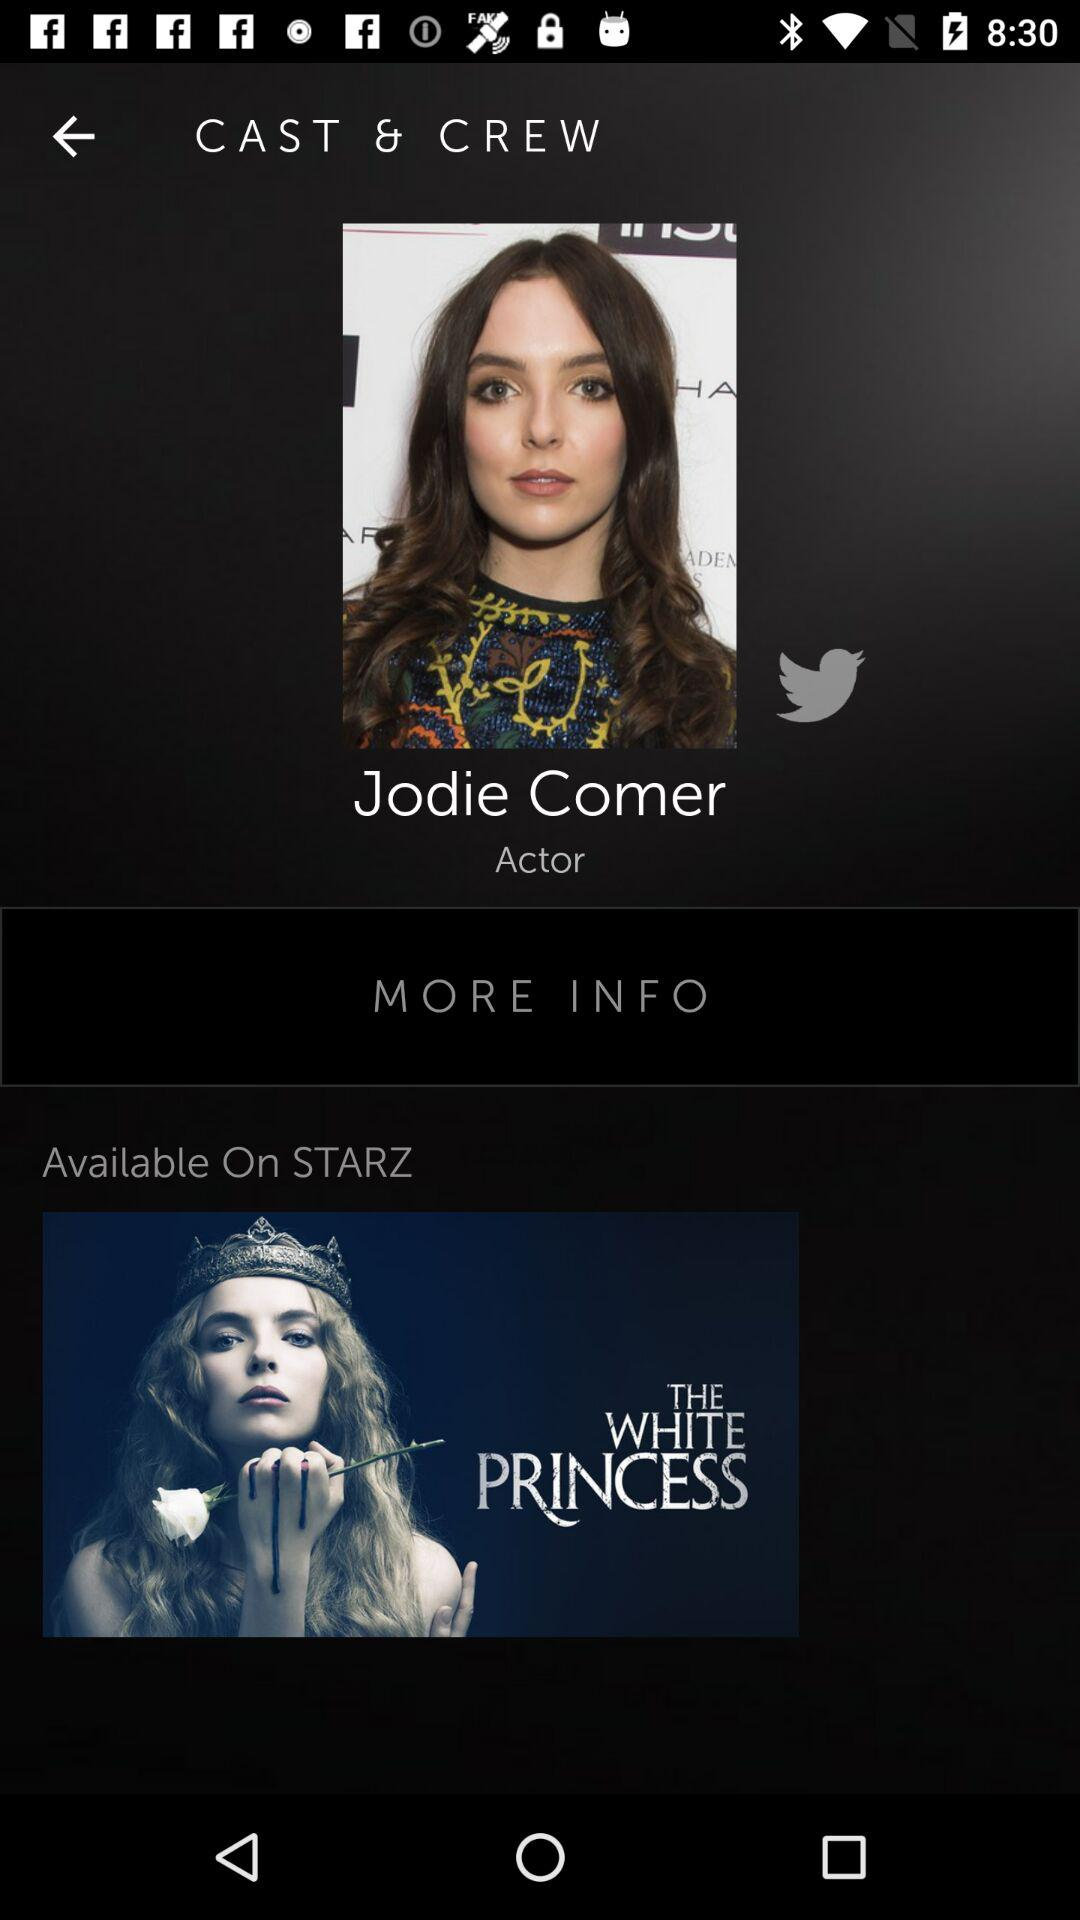What is the name of the movie? The movie name is "The White Princess". 